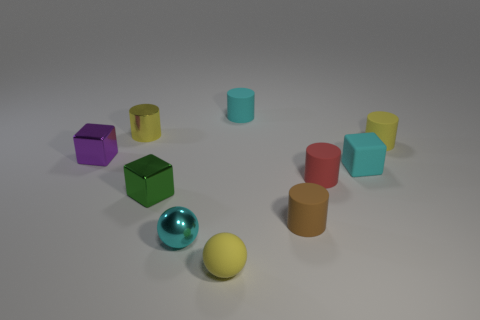Subtract all red matte cylinders. How many cylinders are left? 4 Subtract 2 cubes. How many cubes are left? 1 Subtract all balls. How many objects are left? 8 Subtract all green blocks. How many blocks are left? 2 Subtract 1 cyan cylinders. How many objects are left? 9 Subtract all brown cubes. Subtract all cyan spheres. How many cubes are left? 3 Subtract all yellow cubes. How many cyan spheres are left? 1 Subtract all tiny purple cubes. Subtract all cyan balls. How many objects are left? 8 Add 9 yellow rubber cylinders. How many yellow rubber cylinders are left? 10 Add 4 big cyan metallic spheres. How many big cyan metallic spheres exist? 4 